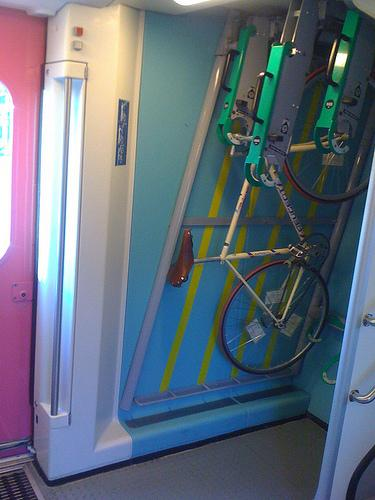Can you provide a brief summary of what's present in the image? The image features a bicycle hanging from a rack, with various parts such as wheels, seat, handlebars, chain, and pedal visible, along with parts of the surrounding environment like the door, wall, floor, and a red light. How many distinctly labeled parts of the bicycle are present in the image? There are 8 distinctly labeled parts of a bicycle: wheels (front and rear), seat, handle bars, pedal, front fork, chain, and chainring. What is the mood or emotion conveyed by the image? The image conveys a sense of organization and storage in an orderly space. Are there any signage or branding visible in the image? Yes, there's a part of a blue sign and the brand name of a bicycle visible. Is the image of high quality, easily allowing objects to be discerned? The image is of sufficient quality to allow for easy identification and understanding of objects and their placements. What is the color of the light on the wall and the floor? The light on the wall is red, and the floor is grey. Count how many metal objects are present in the image? There are four metal objects present in the image. Please describe any object interactions or connections within the image. The bicycle's wheels, seat, handle bars, chain, and pedals are connected and interacting with one another as they form a complete bicycle hanging from the rack. Which object has the largest size in the image and what are its dimensions? The largest object is a bike with dimensions of width 201 and height 201. Identify and count all unique objects in the scene. There are 16 unique objects: various parts of a bike (8), metal objects (4), parts of the wall, door, ground, and window (4), a light on the ceiling, a red light on the wall, and a blue sign. Mention a detail about the light on the ceiling visible in the image. A small part of the light on the ceiling is visible at the top area of the image. Create a poem about the main object in the image. In the land of metal and grey, Provide a fanciful description of the bicycle's various parts. A noble steed with spinning wheels of fortune, a seat to cradle the rider, and handlebars to guide the journey. Is there a window visible in the image? If so, describe its position. Yes, a small part of the window is visible in the left-middle part of the image. Does the bicycle at X:167 Y:29 have a bell located at X:275 Y:179 Width:30 Height:30? The original captions mention a brand name at that position, not a bell. Write a creative caption for the image, mentioning the main object and its surroundings. A proud bicycle, majestically suspended on a rack, amidst a kingdom of metal contraptions. What part of the door is visible in the image? A small section of the door Identify the main object in the image and describe its position. A bike hanging from a rack in the upper central area of the image. Is there a dog at X:199 Y:465 with Width:34 Height:34? There is no mention of any dog in the original captions. What color is the light on the wall? Red Identify a prominent color in the scene and explain its significance. Grey, as it is the color of the floor and some metal objects in the background. Explain the elements present in the diagram of the image. There is no diagram in the image. Is there a picture of a sunset on the wall at X:165 Y:99 Width:27 Height:27? The original captions only mention a part of the wall without any reference to a picture. What event is occurring on this image? No specific event is occurring, just a bicycle hanging on a rack. Is there a visible brand name on the bicycle in the image? Yes What material are the objects at the top part of the image made of? Metal Describe the seat of the bike in the image. A small, slightly elongated seat positioned towards the rear part of the bike. Is the bicycle with a green frame located at X:170 Y:58? The original captions mention a bicycle, but no mention of its color is made.  Choose the correct caption to describe the scene: (a) A bicycle parked in a street (b) A cat laying on a rug (c) A bicycle hanging from a rack A bicycle hanging from a rack Which part of the ground is visible in the image? A small portion of the grey floor Describe the expression of a person present in the image. There is no person in the image. Is the floor with grass texture at X:197 Y:452 Width:75 Height:75? The original captions mention only the grey floor without any reference to grass texture. Is the cat sitting in the window at X:1 Y:186 Width:6 Height:6? There is a mention of a window in the original captions, but no reference to a cat. Compose a haiku that mentions the main object in the image and its surroundings. Bicycle aloft, Identify the activity depicted in the image. A bicycle stored on a rack 